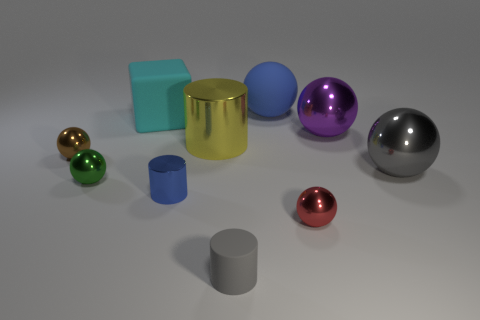Subtract all green balls. How many balls are left? 5 Subtract all brown shiny spheres. How many spheres are left? 5 Subtract 0 purple cubes. How many objects are left? 10 Subtract all balls. How many objects are left? 4 Subtract 1 cylinders. How many cylinders are left? 2 Subtract all yellow cylinders. Subtract all cyan spheres. How many cylinders are left? 2 Subtract all green spheres. How many green cylinders are left? 0 Subtract all large metal cylinders. Subtract all cyan matte blocks. How many objects are left? 8 Add 2 cyan matte cubes. How many cyan matte cubes are left? 3 Add 1 big blue shiny things. How many big blue shiny things exist? 1 